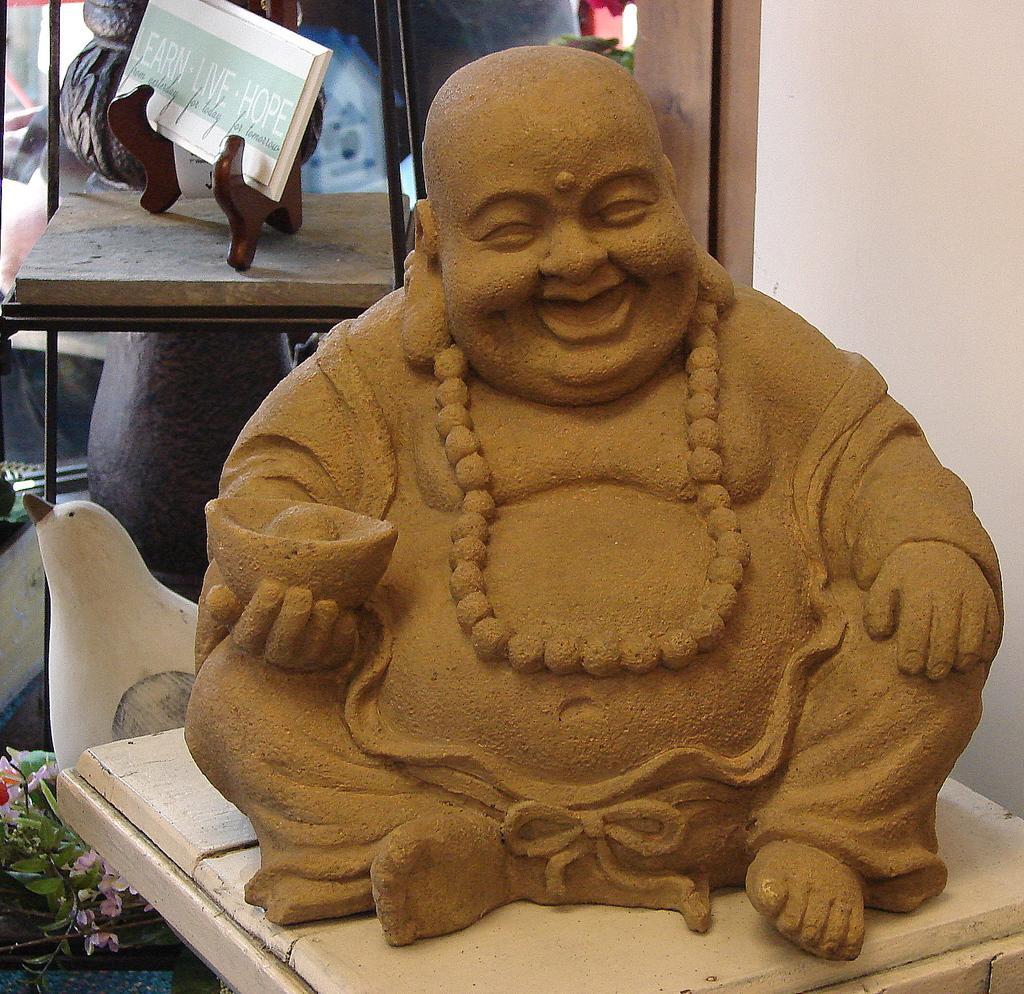Describe this image in one or two sentences. In this image in the center there is a statue. In the background there is a book and there is white colour object. 